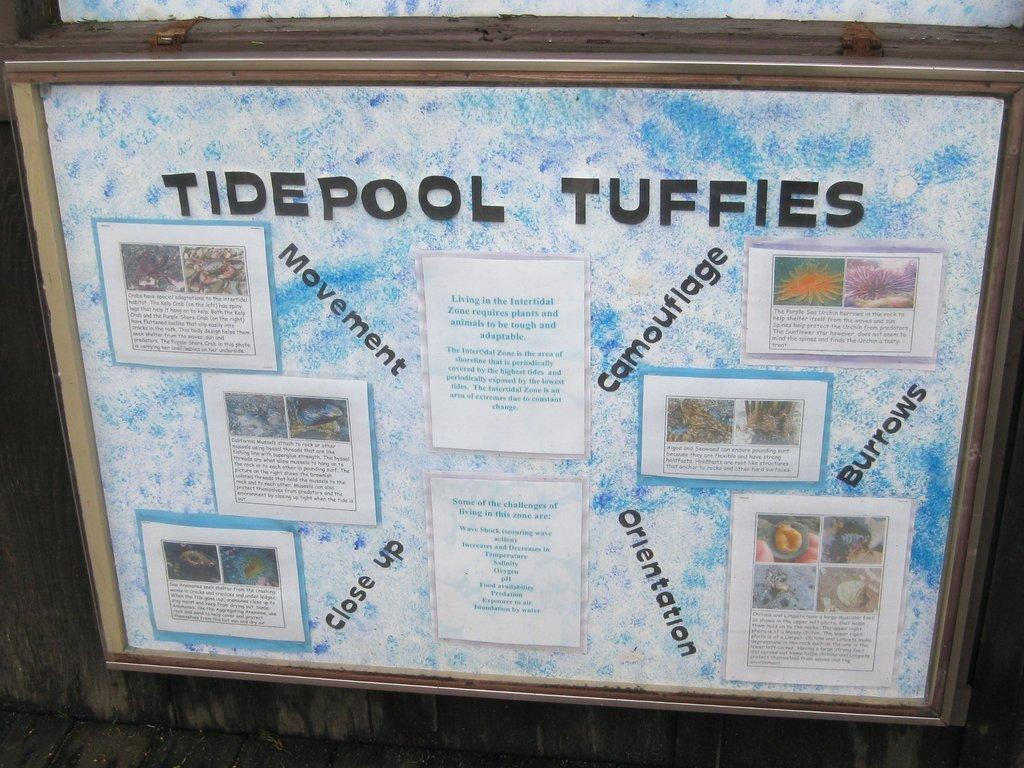<image>
Create a compact narrative representing the image presented. Board that says Tidepool Tuffies in black letters. 